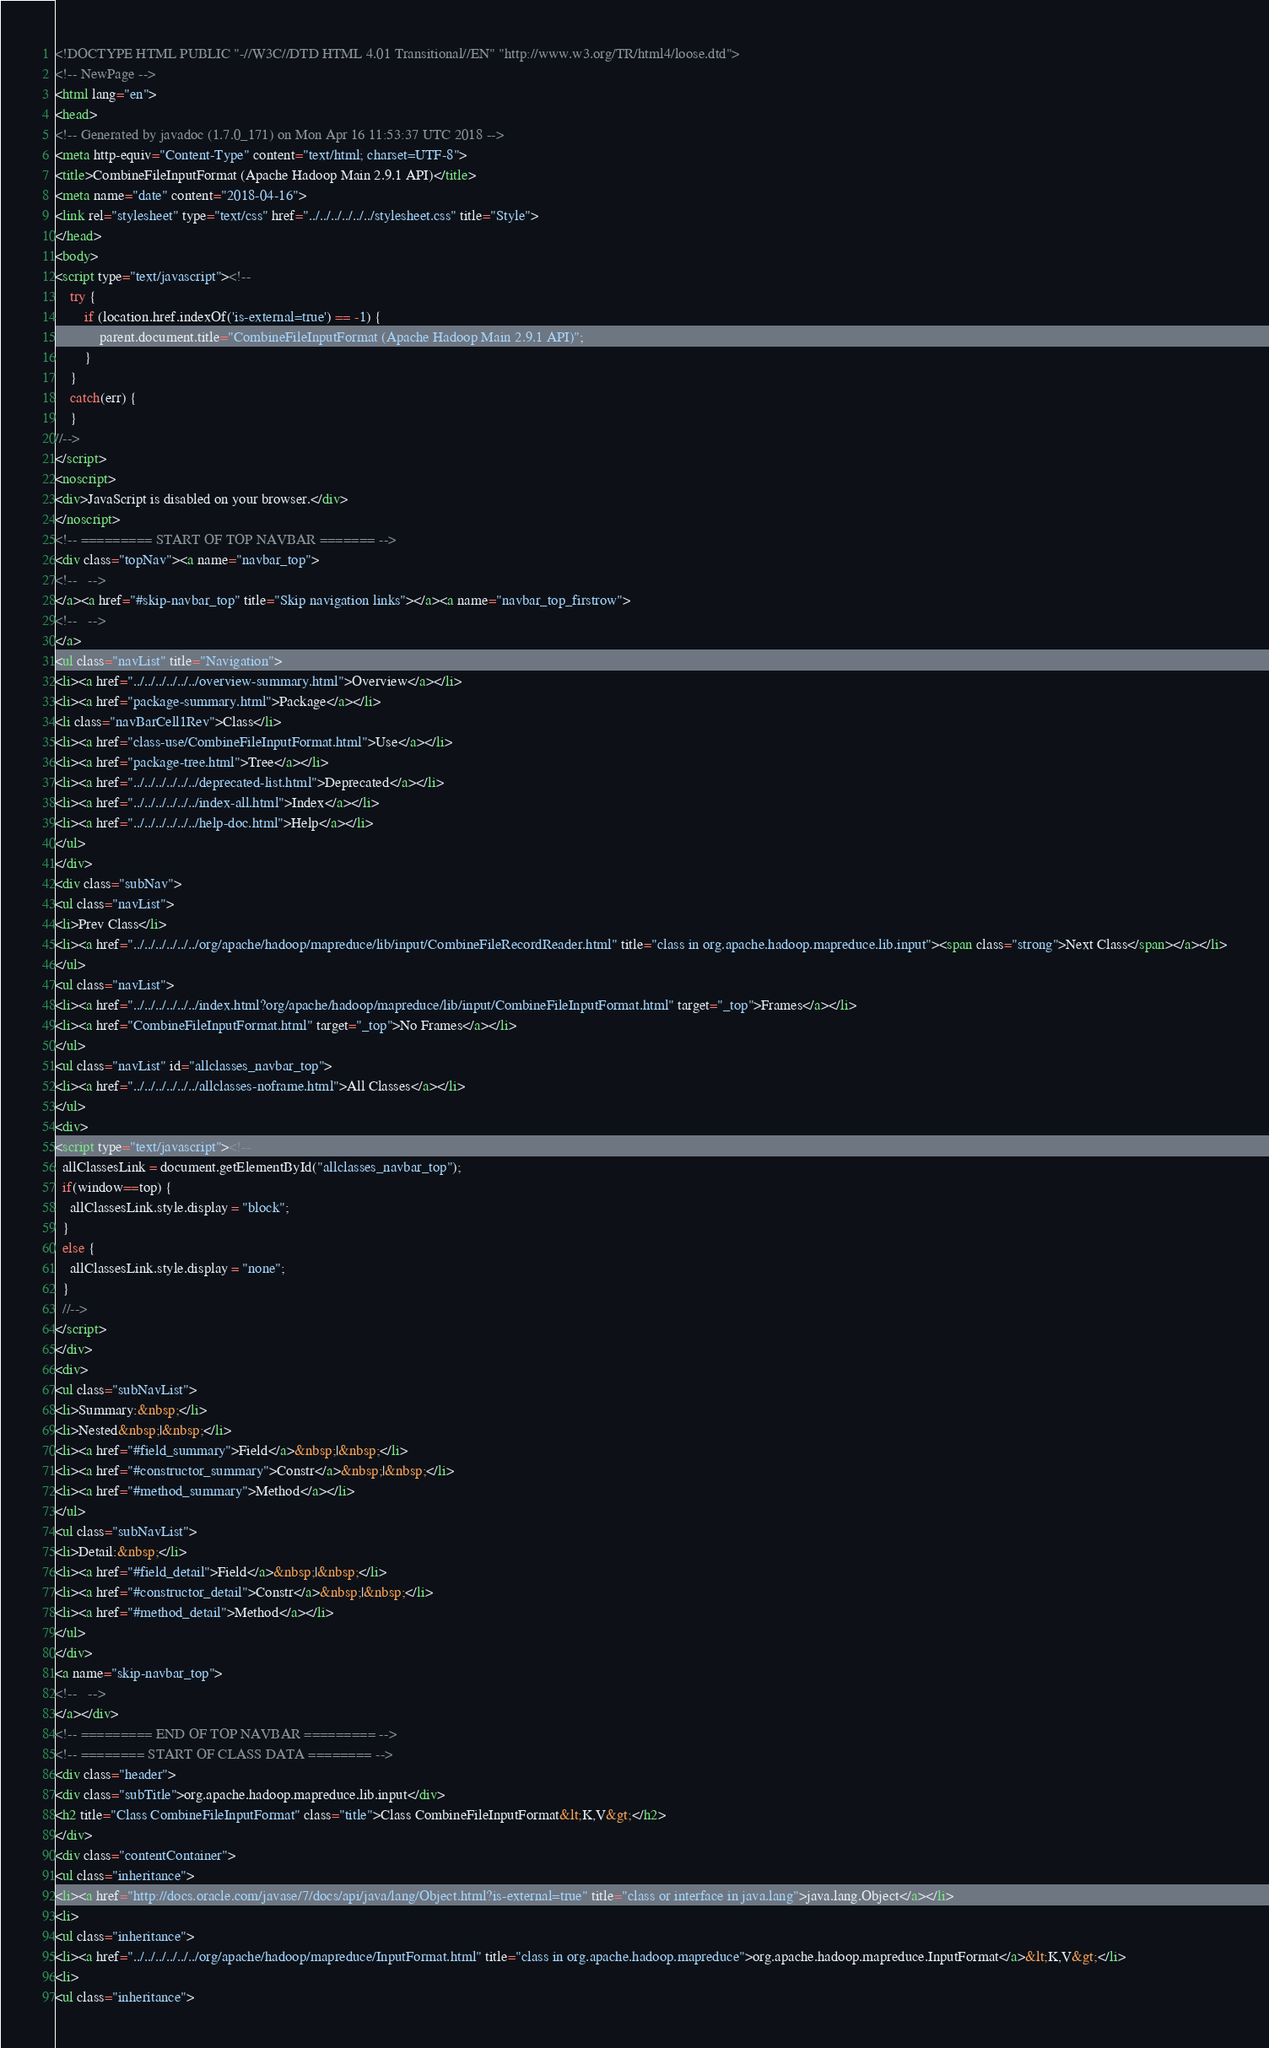<code> <loc_0><loc_0><loc_500><loc_500><_HTML_><!DOCTYPE HTML PUBLIC "-//W3C//DTD HTML 4.01 Transitional//EN" "http://www.w3.org/TR/html4/loose.dtd">
<!-- NewPage -->
<html lang="en">
<head>
<!-- Generated by javadoc (1.7.0_171) on Mon Apr 16 11:53:37 UTC 2018 -->
<meta http-equiv="Content-Type" content="text/html; charset=UTF-8">
<title>CombineFileInputFormat (Apache Hadoop Main 2.9.1 API)</title>
<meta name="date" content="2018-04-16">
<link rel="stylesheet" type="text/css" href="../../../../../../stylesheet.css" title="Style">
</head>
<body>
<script type="text/javascript"><!--
    try {
        if (location.href.indexOf('is-external=true') == -1) {
            parent.document.title="CombineFileInputFormat (Apache Hadoop Main 2.9.1 API)";
        }
    }
    catch(err) {
    }
//-->
</script>
<noscript>
<div>JavaScript is disabled on your browser.</div>
</noscript>
<!-- ========= START OF TOP NAVBAR ======= -->
<div class="topNav"><a name="navbar_top">
<!--   -->
</a><a href="#skip-navbar_top" title="Skip navigation links"></a><a name="navbar_top_firstrow">
<!--   -->
</a>
<ul class="navList" title="Navigation">
<li><a href="../../../../../../overview-summary.html">Overview</a></li>
<li><a href="package-summary.html">Package</a></li>
<li class="navBarCell1Rev">Class</li>
<li><a href="class-use/CombineFileInputFormat.html">Use</a></li>
<li><a href="package-tree.html">Tree</a></li>
<li><a href="../../../../../../deprecated-list.html">Deprecated</a></li>
<li><a href="../../../../../../index-all.html">Index</a></li>
<li><a href="../../../../../../help-doc.html">Help</a></li>
</ul>
</div>
<div class="subNav">
<ul class="navList">
<li>Prev Class</li>
<li><a href="../../../../../../org/apache/hadoop/mapreduce/lib/input/CombineFileRecordReader.html" title="class in org.apache.hadoop.mapreduce.lib.input"><span class="strong">Next Class</span></a></li>
</ul>
<ul class="navList">
<li><a href="../../../../../../index.html?org/apache/hadoop/mapreduce/lib/input/CombineFileInputFormat.html" target="_top">Frames</a></li>
<li><a href="CombineFileInputFormat.html" target="_top">No Frames</a></li>
</ul>
<ul class="navList" id="allclasses_navbar_top">
<li><a href="../../../../../../allclasses-noframe.html">All Classes</a></li>
</ul>
<div>
<script type="text/javascript"><!--
  allClassesLink = document.getElementById("allclasses_navbar_top");
  if(window==top) {
    allClassesLink.style.display = "block";
  }
  else {
    allClassesLink.style.display = "none";
  }
  //-->
</script>
</div>
<div>
<ul class="subNavList">
<li>Summary:&nbsp;</li>
<li>Nested&nbsp;|&nbsp;</li>
<li><a href="#field_summary">Field</a>&nbsp;|&nbsp;</li>
<li><a href="#constructor_summary">Constr</a>&nbsp;|&nbsp;</li>
<li><a href="#method_summary">Method</a></li>
</ul>
<ul class="subNavList">
<li>Detail:&nbsp;</li>
<li><a href="#field_detail">Field</a>&nbsp;|&nbsp;</li>
<li><a href="#constructor_detail">Constr</a>&nbsp;|&nbsp;</li>
<li><a href="#method_detail">Method</a></li>
</ul>
</div>
<a name="skip-navbar_top">
<!--   -->
</a></div>
<!-- ========= END OF TOP NAVBAR ========= -->
<!-- ======== START OF CLASS DATA ======== -->
<div class="header">
<div class="subTitle">org.apache.hadoop.mapreduce.lib.input</div>
<h2 title="Class CombineFileInputFormat" class="title">Class CombineFileInputFormat&lt;K,V&gt;</h2>
</div>
<div class="contentContainer">
<ul class="inheritance">
<li><a href="http://docs.oracle.com/javase/7/docs/api/java/lang/Object.html?is-external=true" title="class or interface in java.lang">java.lang.Object</a></li>
<li>
<ul class="inheritance">
<li><a href="../../../../../../org/apache/hadoop/mapreduce/InputFormat.html" title="class in org.apache.hadoop.mapreduce">org.apache.hadoop.mapreduce.InputFormat</a>&lt;K,V&gt;</li>
<li>
<ul class="inheritance"></code> 